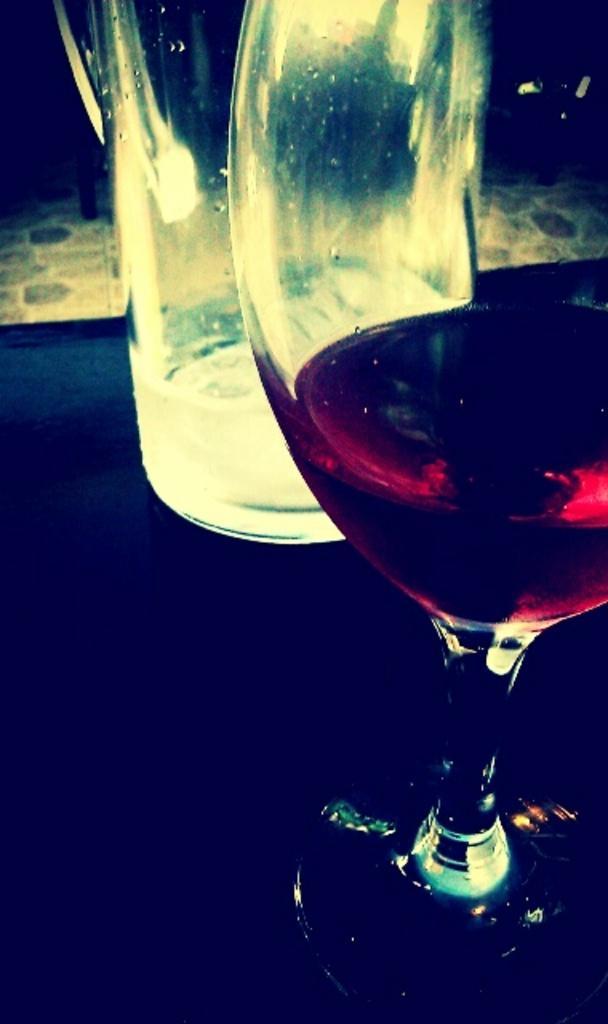In one or two sentences, can you explain what this image depicts? In this image I can see on the right side it is a wine glass, at the top it looks like a bottle. 